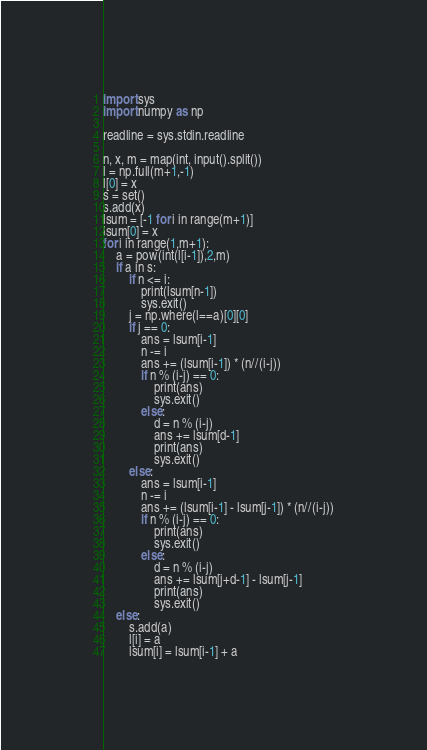<code> <loc_0><loc_0><loc_500><loc_500><_Python_>import sys
import numpy as np

readline = sys.stdin.readline

n, x, m = map(int, input().split())
l = np.full(m+1,-1)
l[0] = x
s = set()
s.add(x)
lsum = [-1 for i in range(m+1)]
lsum[0] = x
for i in range(1,m+1):
    a = pow(int(l[i-1]),2,m)
    if a in s:
        if n <= i:
            print(lsum[n-1])
            sys.exit()
        j = np.where(l==a)[0][0]
        if j == 0:
            ans = lsum[i-1]
            n -= i
            ans += (lsum[i-1]) * (n//(i-j))
            if n % (i-j) == 0:
                print(ans)
                sys.exit()
            else:
                d = n % (i-j)
                ans += lsum[d-1]
                print(ans)
                sys.exit()
        else:
            ans = lsum[i-1]
            n -= i
            ans += (lsum[i-1] - lsum[j-1]) * (n//(i-j))
            if n % (i-j) == 0:
                print(ans)
                sys.exit()
            else:
                d = n % (i-j)
                ans += lsum[j+d-1] - lsum[j-1]
                print(ans)
                sys.exit()
    else:
        s.add(a)
        l[i] = a
        lsum[i] = lsum[i-1] + a
</code> 